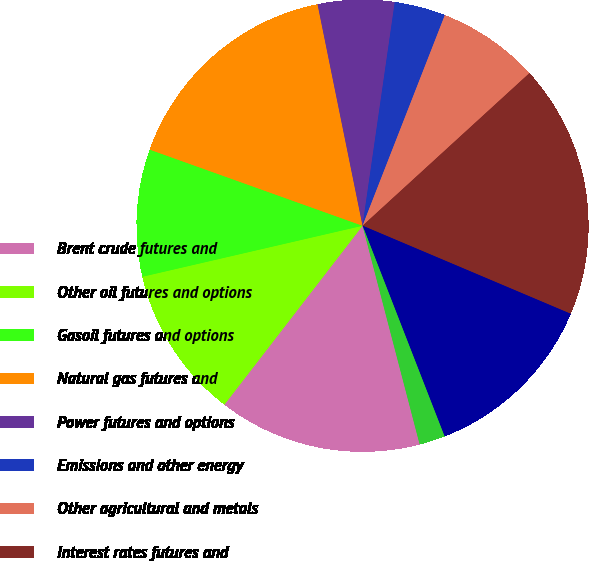Convert chart. <chart><loc_0><loc_0><loc_500><loc_500><pie_chart><fcel>Brent crude futures and<fcel>Other oil futures and options<fcel>Gasoil futures and options<fcel>Natural gas futures and<fcel>Power futures and options<fcel>Emissions and other energy<fcel>Other agricultural and metals<fcel>Interest rates futures and<fcel>Other financial futures and<fcel>Agricultural and metals<nl><fcel>14.53%<fcel>10.91%<fcel>9.09%<fcel>16.34%<fcel>5.47%<fcel>3.65%<fcel>7.28%<fcel>18.16%<fcel>12.72%<fcel>1.84%<nl></chart> 